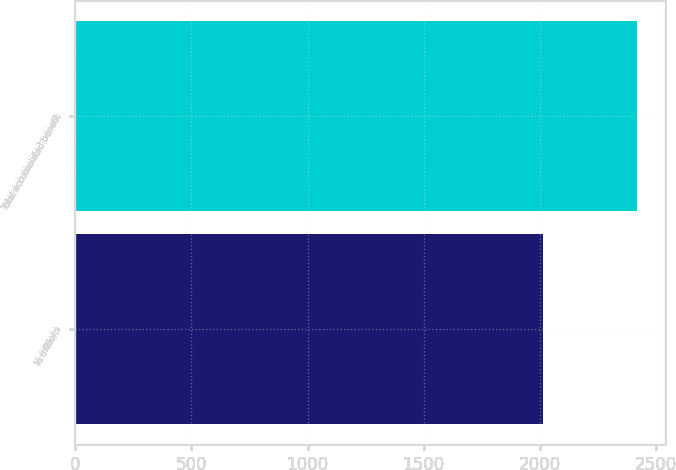Convert chart. <chart><loc_0><loc_0><loc_500><loc_500><bar_chart><fcel>In millions<fcel>Total accumulated benefit<nl><fcel>2012<fcel>2417<nl></chart> 